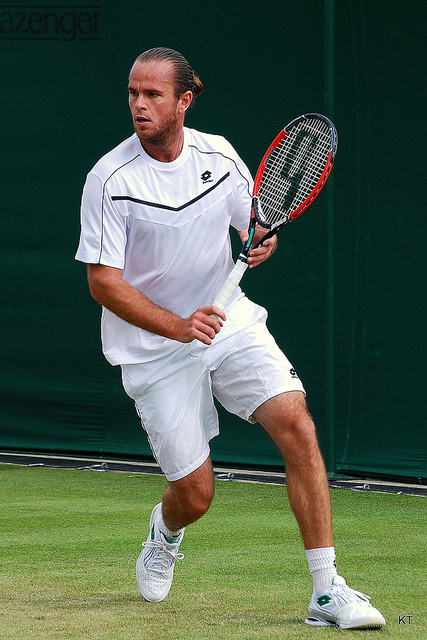Identify the text contained in this image. azenger KT 